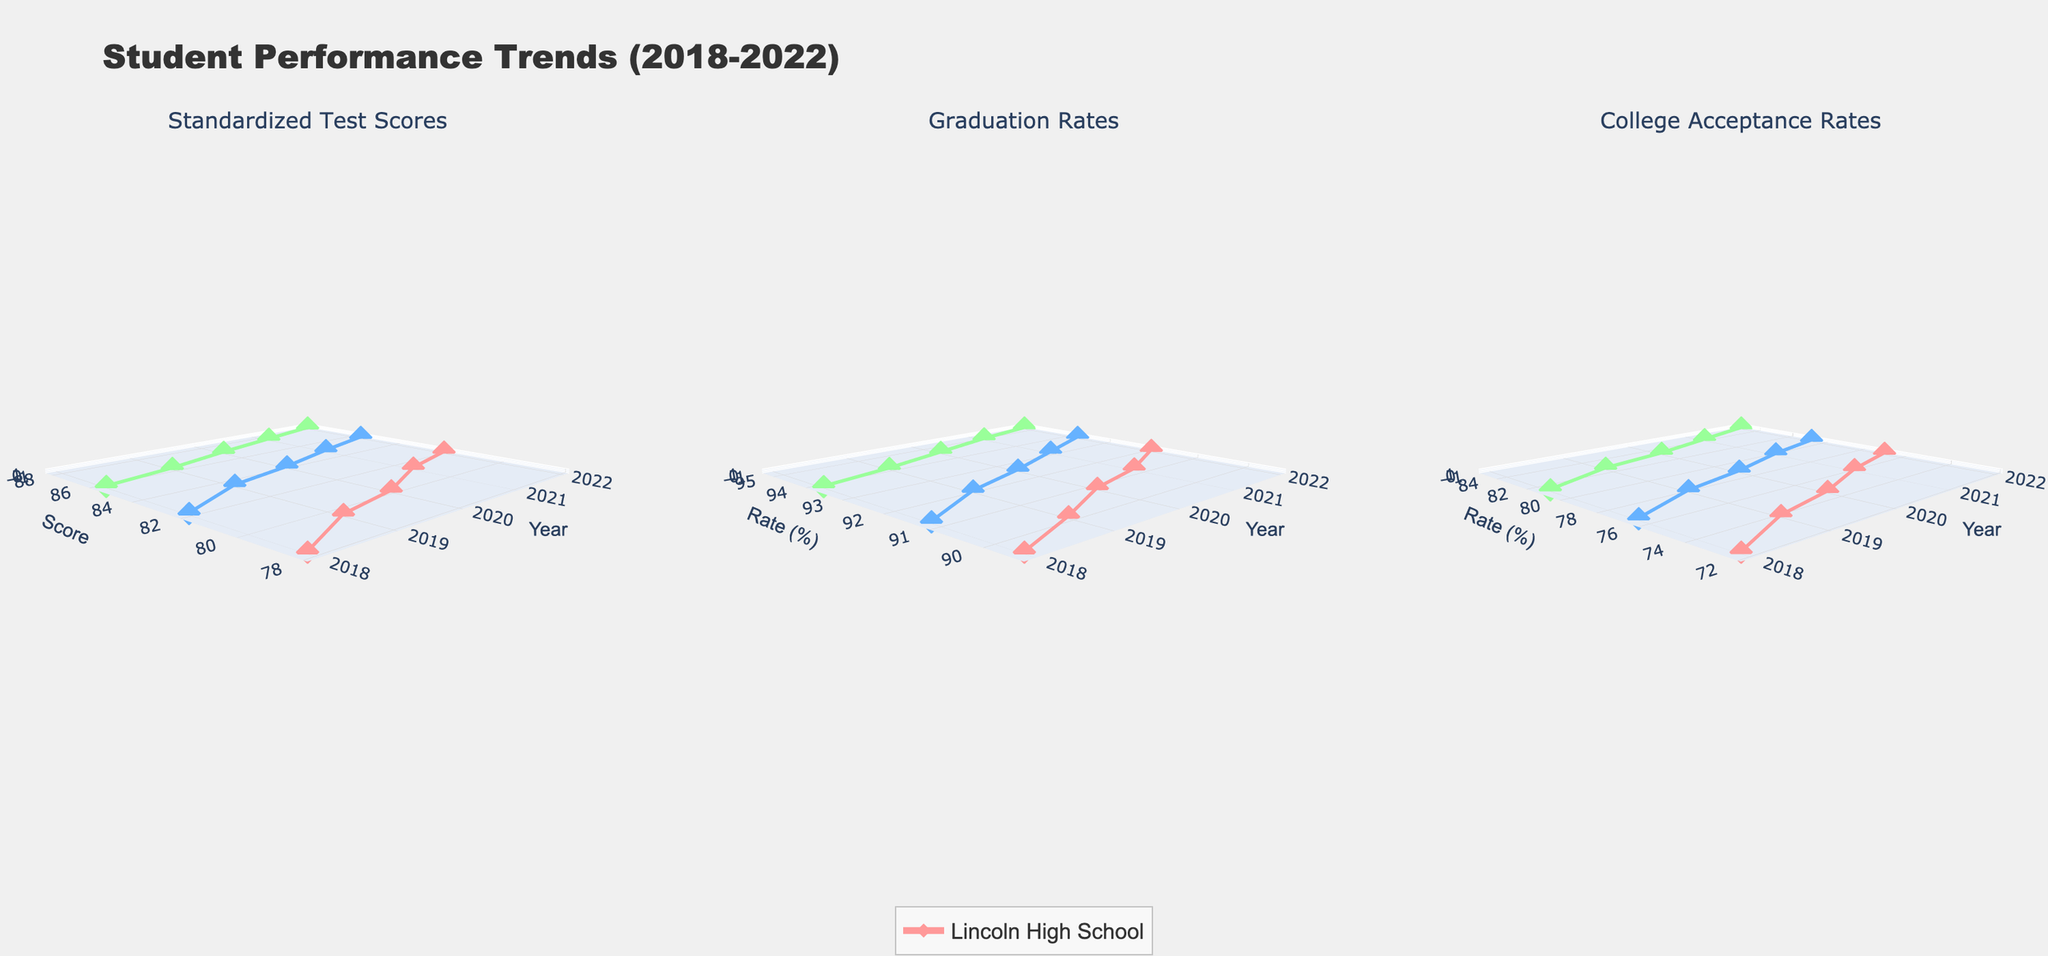What is the title of the figure? The title is located at the top of the figure. It provides an overview of what the figure is about.
Answer: Student Performance Trends (2018-2022) What are the three subplots displaying? The three subplots are indicated by their titles. The first subplot shows Standardized Test Scores, the second shows Graduation Rates, and the third shows College Acceptance Rates.
Answer: Standardized Test Scores, Graduation Rates, College Acceptance Rates Which school had the highest standardized test scores in 2022? To find this, locate the data points on the first subplot for the year 2022 and compare the scores of the three schools. Roosevelt Prep has the highest score.
Answer: Roosevelt Prep How did Lincoln High School’s graduation rate change from 2019 to 2022? Locate the data points in the second subplot for Lincoln High School for the years 2019 and 2022, and then compare the values. It increased from 90.1% to 91.9%.
Answer: Increased What is the average graduation rate of Washington Academy from 2018 to 2022? Note down the graduation rates for Washington Academy across the years (91.2, 92.0, 92.5, 93.1, 93.7). Sum these values and divide by the number of years. Calculation: (91.2 + 92.0 + 92.5 + 93.1 + 93.7) / 5 = 92.5
Answer: 92.5 Which school shows the most consistent trend in college acceptance rates? Compare the fluctuations in the college acceptance rates for each school across the third subplot. Washington Academy shows the most consistent trend with smaller variations.
Answer: Washington Academy What was the difference in standardized test scores between Roosevelt Prep and Lincoln High School in 2018? Locate the standardized test scores for both schools in 2018 in the first subplot and subtract Lincoln High School’s score from Roosevelt Prep’s score. Calculation: 85.7 - 78.2 = 7.5
Answer: 7.5 Which year shows the highest graduation rate for Roosevelt Prep? Check the second subplot for the graduation rates of Roosevelt Prep across all years. The highest rate is visible in the year 2022 at 95.2%.
Answer: 2022 How do the college acceptance rates of Roosevelt Prep in 2022 compare to those in 2018? Locate the college acceptance rates for Roosevelt Prep in the year 2018 and 2022 in the third subplot and compare them. The rate increased from 81.2% to 84.9%.
Answer: Increased In which year did Washington Academy have the highest standardized test score? Check the first subplot for the highest standardized test score of Washington Academy across all years. The highest score is in 2022, which is 85.5.
Answer: 2022 